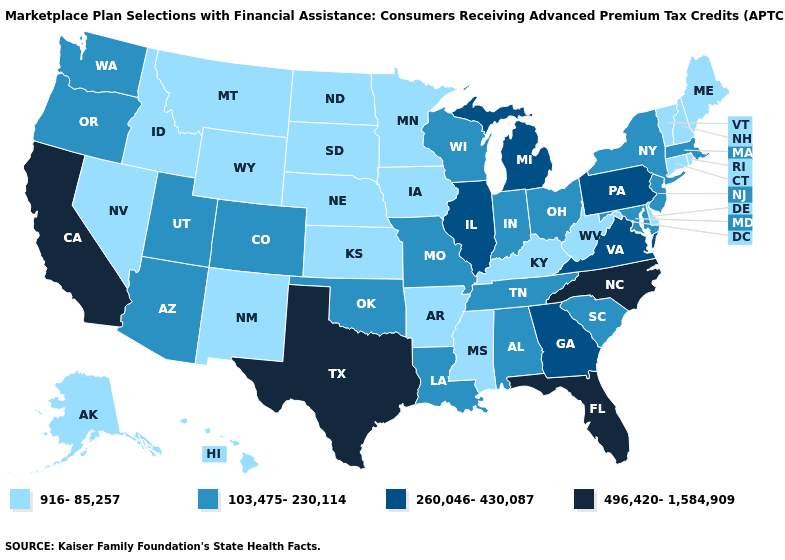How many symbols are there in the legend?
Give a very brief answer. 4. What is the lowest value in the Northeast?
Keep it brief. 916-85,257. What is the value of South Dakota?
Write a very short answer. 916-85,257. Which states have the lowest value in the USA?
Give a very brief answer. Alaska, Arkansas, Connecticut, Delaware, Hawaii, Idaho, Iowa, Kansas, Kentucky, Maine, Minnesota, Mississippi, Montana, Nebraska, Nevada, New Hampshire, New Mexico, North Dakota, Rhode Island, South Dakota, Vermont, West Virginia, Wyoming. Does Texas have the highest value in the USA?
Be succinct. Yes. Does Maryland have the highest value in the South?
Answer briefly. No. Among the states that border North Carolina , does South Carolina have the highest value?
Quick response, please. No. What is the highest value in the USA?
Answer briefly. 496,420-1,584,909. What is the lowest value in the MidWest?
Short answer required. 916-85,257. Name the states that have a value in the range 916-85,257?
Short answer required. Alaska, Arkansas, Connecticut, Delaware, Hawaii, Idaho, Iowa, Kansas, Kentucky, Maine, Minnesota, Mississippi, Montana, Nebraska, Nevada, New Hampshire, New Mexico, North Dakota, Rhode Island, South Dakota, Vermont, West Virginia, Wyoming. Name the states that have a value in the range 103,475-230,114?
Concise answer only. Alabama, Arizona, Colorado, Indiana, Louisiana, Maryland, Massachusetts, Missouri, New Jersey, New York, Ohio, Oklahoma, Oregon, South Carolina, Tennessee, Utah, Washington, Wisconsin. What is the highest value in states that border Idaho?
Short answer required. 103,475-230,114. What is the value of Connecticut?
Quick response, please. 916-85,257. Name the states that have a value in the range 260,046-430,087?
Concise answer only. Georgia, Illinois, Michigan, Pennsylvania, Virginia. 